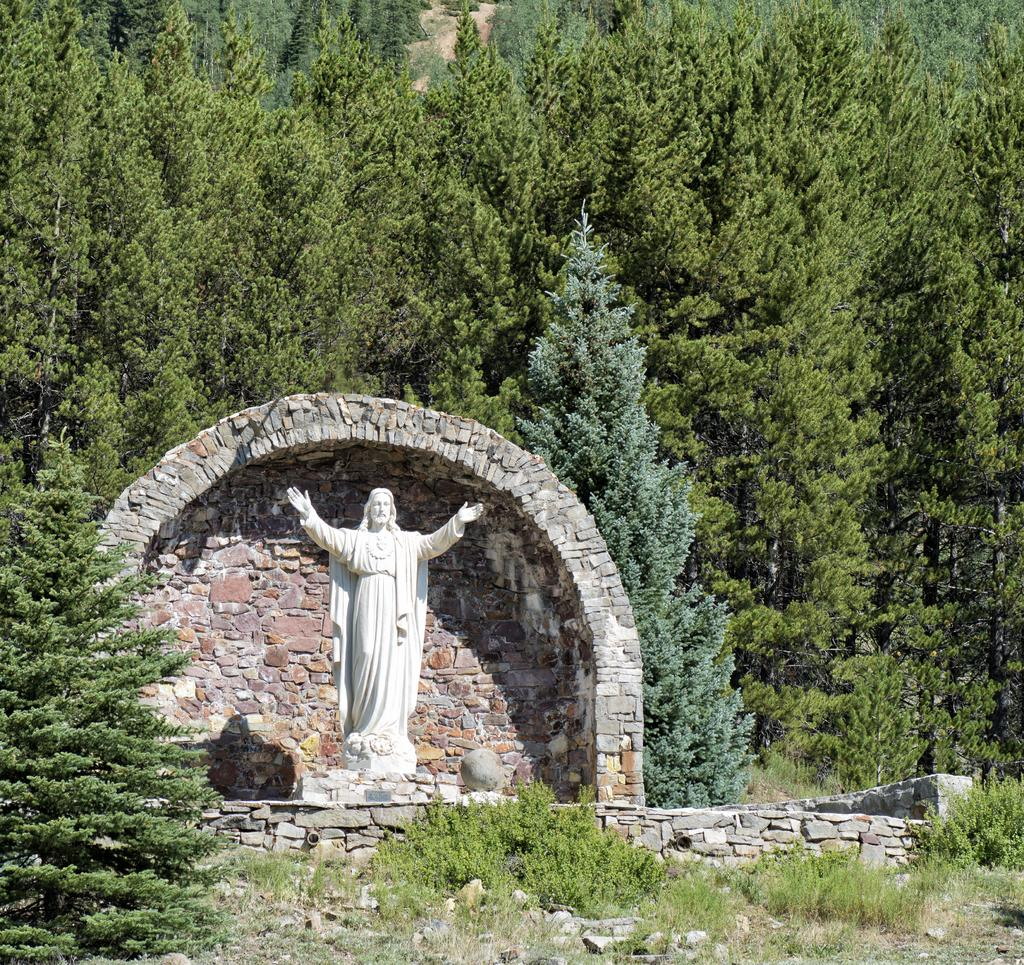What types of objects can be seen in the foreground of the picture? In the foreground of the picture, there are plants, stones, trees, a brick wall, and a sculpture. Can you describe the vegetation in the foreground? The vegetation in the foreground includes plants and trees. What is the material of the wall in the foreground? The wall in the foreground is made of bricks. What is the main subject in the foreground of the picture? The main subject in the foreground of the picture is a sculpture. What can be seen in the background of the picture? In the background of the picture, there are trees. What religious symbols can be seen in the picture? There are no religious symbols present in the image. What type of protest is depicted in the picture? There is no protest depicted in the image; it features plants, stones, trees, a brick wall, and a sculpture in the foreground, with trees in the background. 